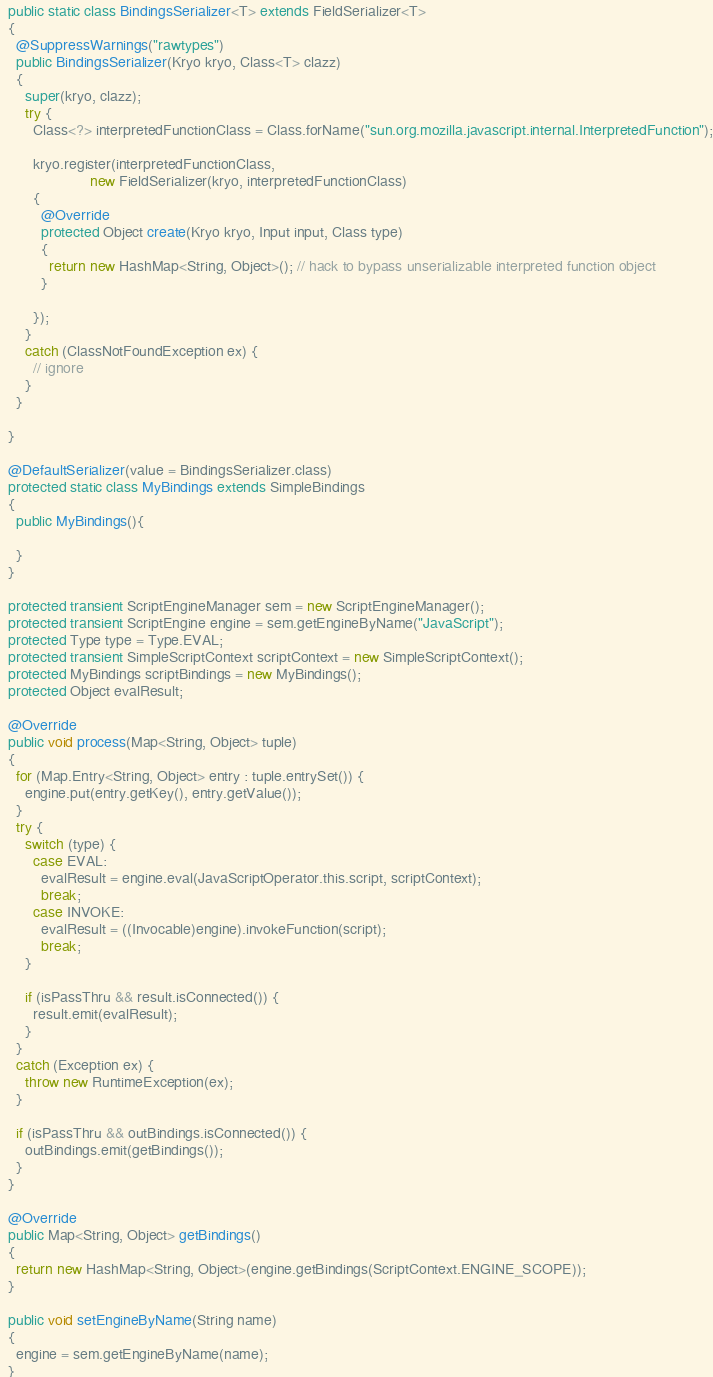Convert code to text. <code><loc_0><loc_0><loc_500><loc_500><_Java_>  public static class BindingsSerializer<T> extends FieldSerializer<T>
  {
    @SuppressWarnings("rawtypes")
    public BindingsSerializer(Kryo kryo, Class<T> clazz)
    {
      super(kryo, clazz);
      try {
        Class<?> interpretedFunctionClass = Class.forName("sun.org.mozilla.javascript.internal.InterpretedFunction");

        kryo.register(interpretedFunctionClass,
                      new FieldSerializer(kryo, interpretedFunctionClass)
        {
          @Override
          protected Object create(Kryo kryo, Input input, Class type)
          {
            return new HashMap<String, Object>(); // hack to bypass unserializable interpreted function object
          }

        });
      }
      catch (ClassNotFoundException ex) {
        // ignore
      }
    }

  }

  @DefaultSerializer(value = BindingsSerializer.class)
  protected static class MyBindings extends SimpleBindings
  {
    public MyBindings(){
      
    }
  }

  protected transient ScriptEngineManager sem = new ScriptEngineManager();
  protected transient ScriptEngine engine = sem.getEngineByName("JavaScript");
  protected Type type = Type.EVAL;
  protected transient SimpleScriptContext scriptContext = new SimpleScriptContext();
  protected MyBindings scriptBindings = new MyBindings();
  protected Object evalResult;

  @Override
  public void process(Map<String, Object> tuple)
  {
    for (Map.Entry<String, Object> entry : tuple.entrySet()) {
      engine.put(entry.getKey(), entry.getValue());
    }
    try {
      switch (type) {
        case EVAL:
          evalResult = engine.eval(JavaScriptOperator.this.script, scriptContext);
          break;
        case INVOKE:
          evalResult = ((Invocable)engine).invokeFunction(script);
          break;
      }

      if (isPassThru && result.isConnected()) {
        result.emit(evalResult);
      }
    }
    catch (Exception ex) {
      throw new RuntimeException(ex);
    }

    if (isPassThru && outBindings.isConnected()) {
      outBindings.emit(getBindings());
    }
  }

  @Override
  public Map<String, Object> getBindings()
  {
    return new HashMap<String, Object>(engine.getBindings(ScriptContext.ENGINE_SCOPE));
  }

  public void setEngineByName(String name)
  {
    engine = sem.getEngineByName(name);
  }

</code> 